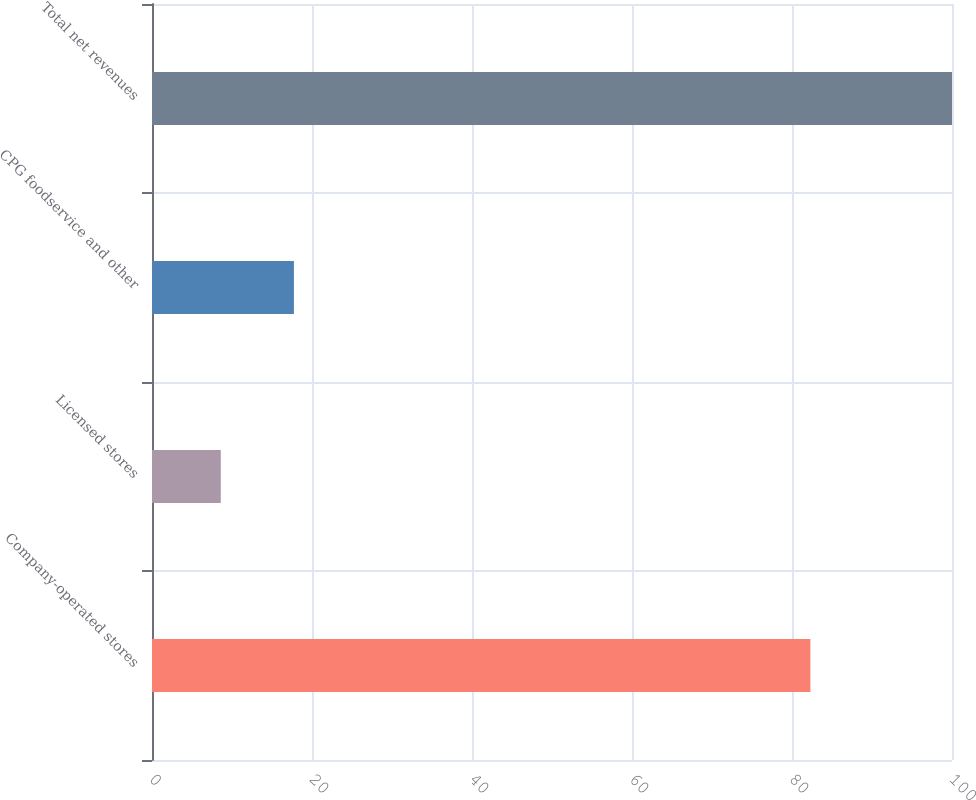<chart> <loc_0><loc_0><loc_500><loc_500><bar_chart><fcel>Company-operated stores<fcel>Licensed stores<fcel>CPG foodservice and other<fcel>Total net revenues<nl><fcel>82.3<fcel>8.6<fcel>17.74<fcel>100<nl></chart> 